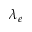<formula> <loc_0><loc_0><loc_500><loc_500>\lambda _ { e }</formula> 